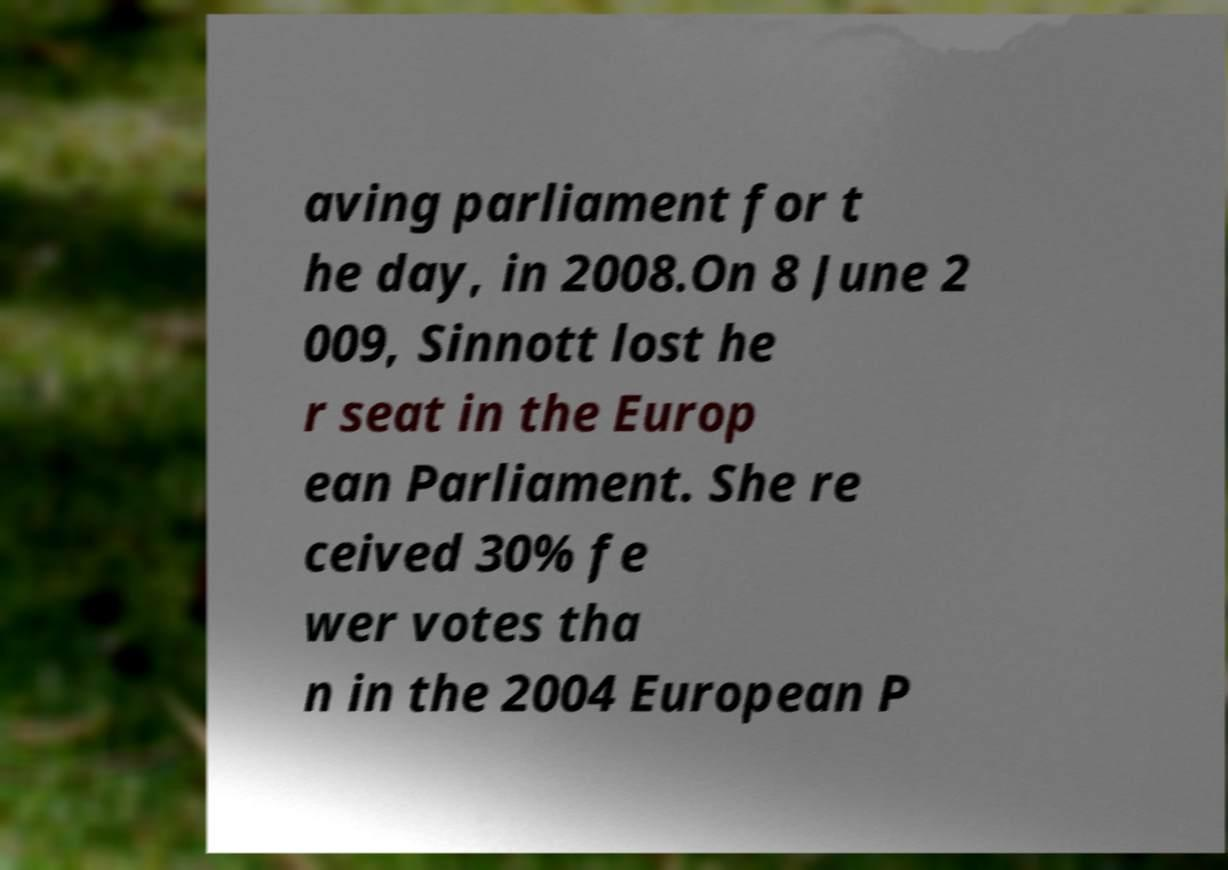Could you assist in decoding the text presented in this image and type it out clearly? aving parliament for t he day, in 2008.On 8 June 2 009, Sinnott lost he r seat in the Europ ean Parliament. She re ceived 30% fe wer votes tha n in the 2004 European P 